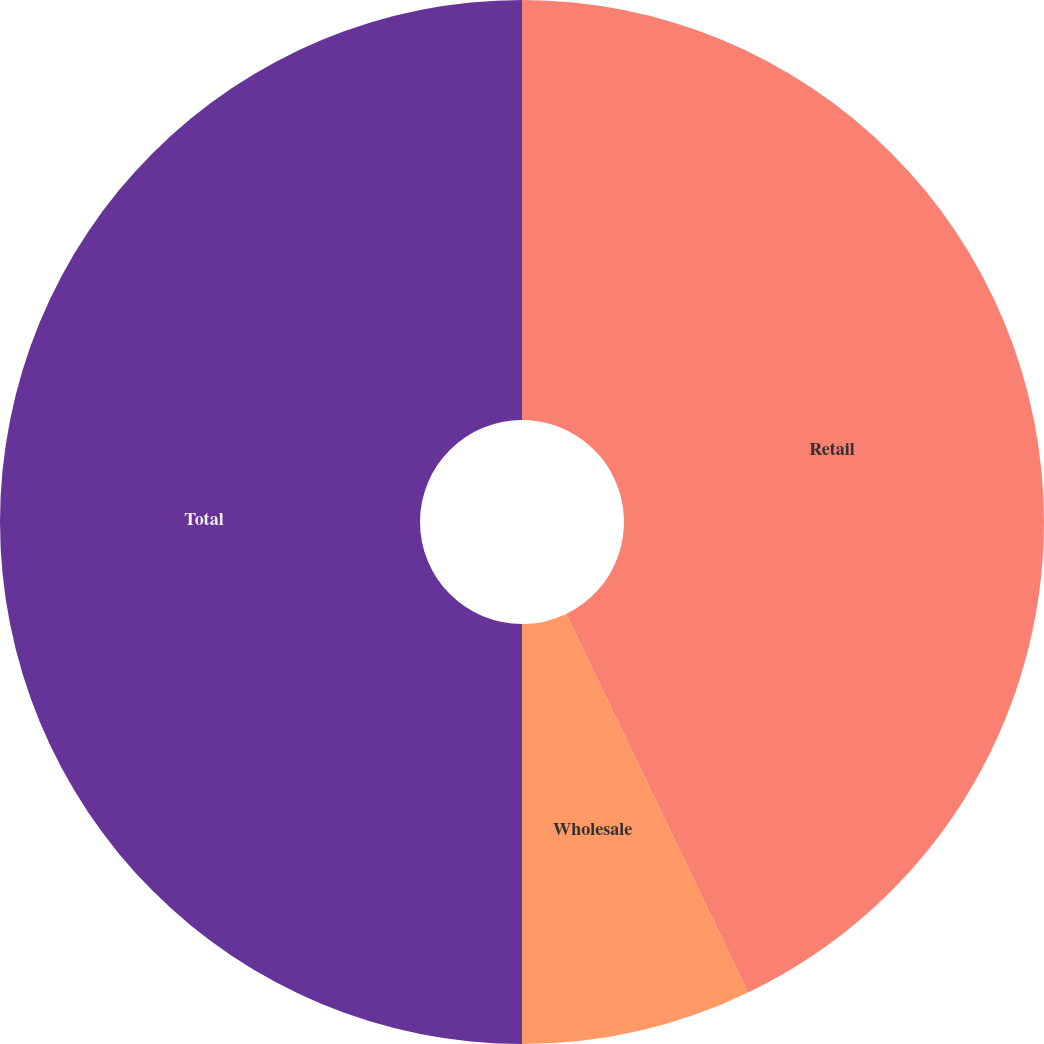<chart> <loc_0><loc_0><loc_500><loc_500><pie_chart><fcel>Retail<fcel>Wholesale<fcel>Total<nl><fcel>42.87%<fcel>7.13%<fcel>50.0%<nl></chart> 